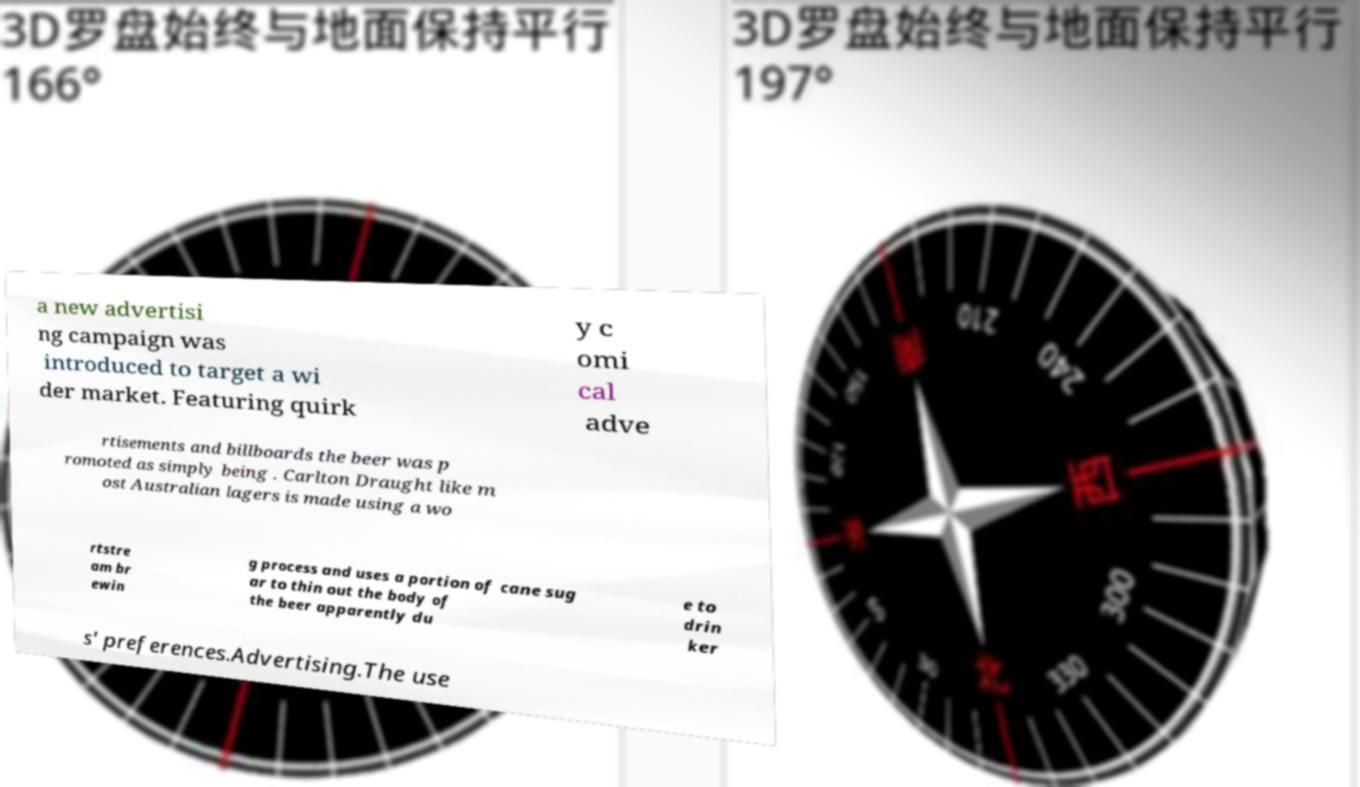Can you accurately transcribe the text from the provided image for me? a new advertisi ng campaign was introduced to target a wi der market. Featuring quirk y c omi cal adve rtisements and billboards the beer was p romoted as simply being . Carlton Draught like m ost Australian lagers is made using a wo rtstre am br ewin g process and uses a portion of cane sug ar to thin out the body of the beer apparently du e to drin ker s' preferences.Advertising.The use 